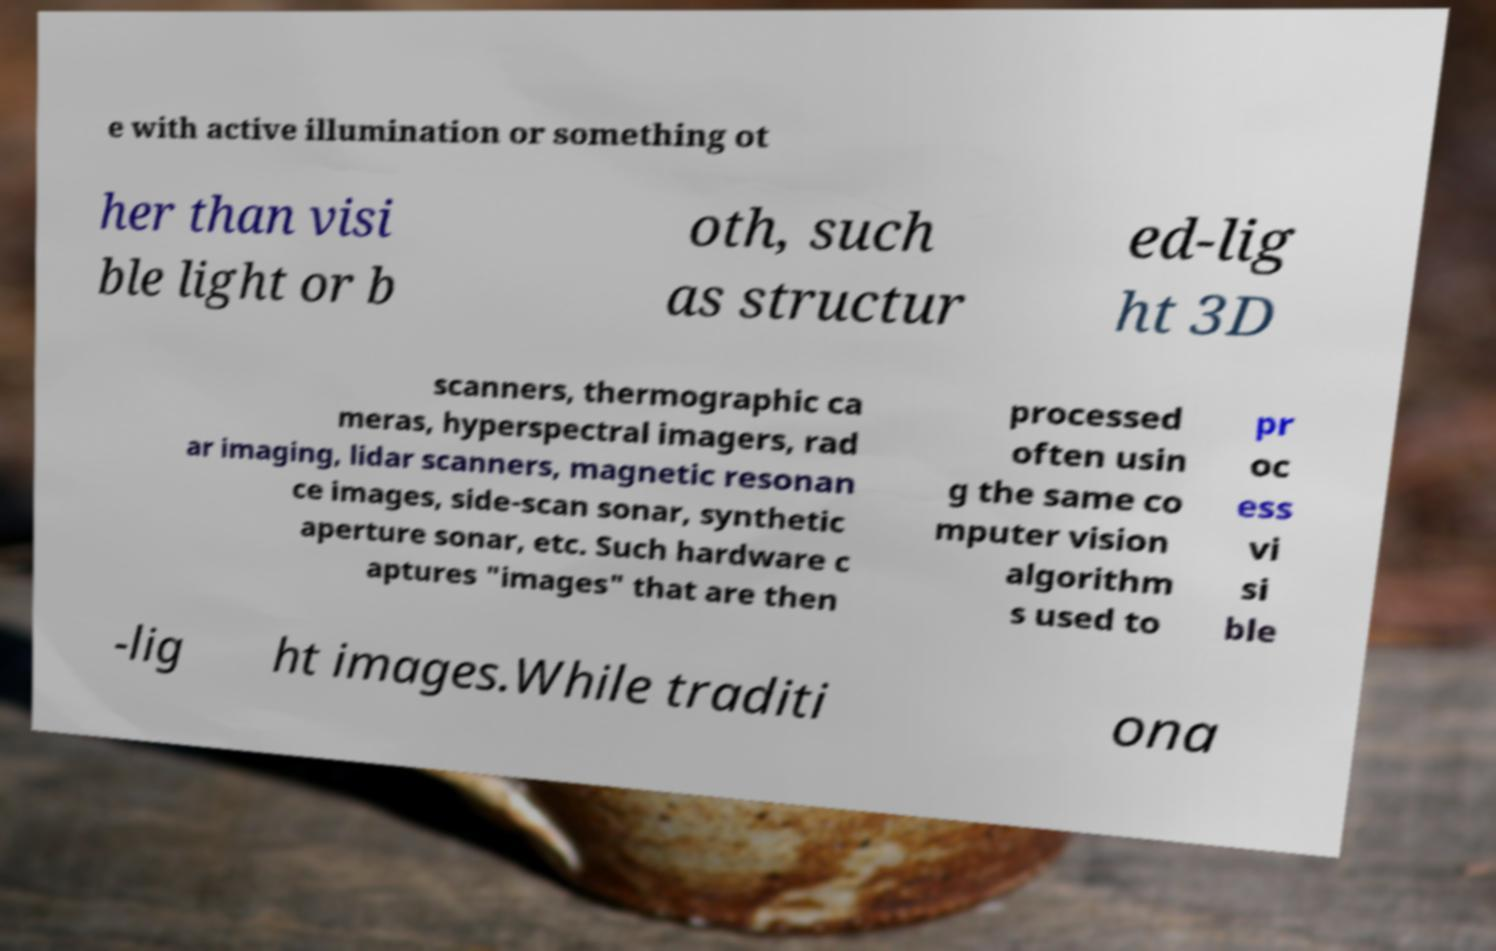For documentation purposes, I need the text within this image transcribed. Could you provide that? e with active illumination or something ot her than visi ble light or b oth, such as structur ed-lig ht 3D scanners, thermographic ca meras, hyperspectral imagers, rad ar imaging, lidar scanners, magnetic resonan ce images, side-scan sonar, synthetic aperture sonar, etc. Such hardware c aptures "images" that are then processed often usin g the same co mputer vision algorithm s used to pr oc ess vi si ble -lig ht images.While traditi ona 